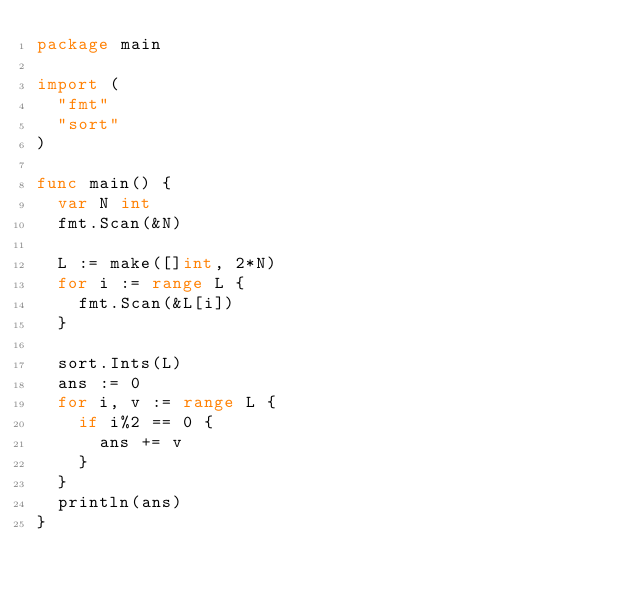Convert code to text. <code><loc_0><loc_0><loc_500><loc_500><_Go_>package main

import (
	"fmt"
	"sort"
)

func main() {
	var N int
	fmt.Scan(&N)

	L := make([]int, 2*N)
	for i := range L {
		fmt.Scan(&L[i])
	}

	sort.Ints(L)
	ans := 0
	for i, v := range L {
		if i%2 == 0 {
			ans += v
		}
	}
	println(ans)
}
</code> 